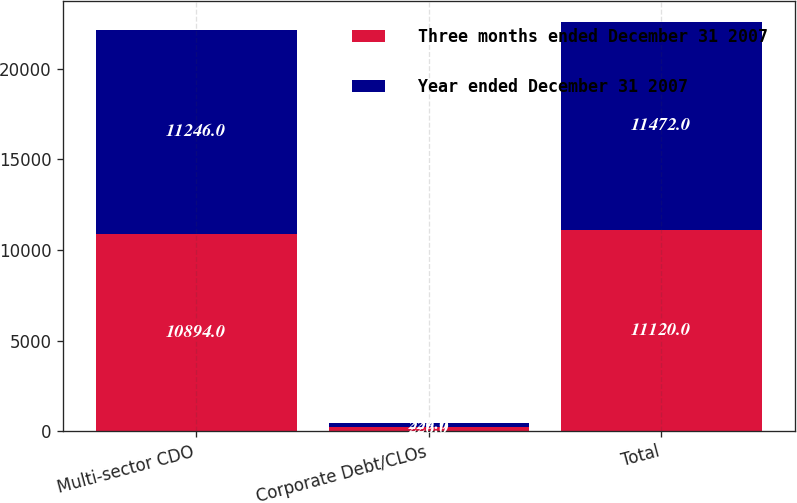Convert chart. <chart><loc_0><loc_0><loc_500><loc_500><stacked_bar_chart><ecel><fcel>Multi-sector CDO<fcel>Corporate Debt/CLOs<fcel>Total<nl><fcel>Three months ended December 31 2007<fcel>10894<fcel>226<fcel>11120<nl><fcel>Year ended December 31 2007<fcel>11246<fcel>226<fcel>11472<nl></chart> 